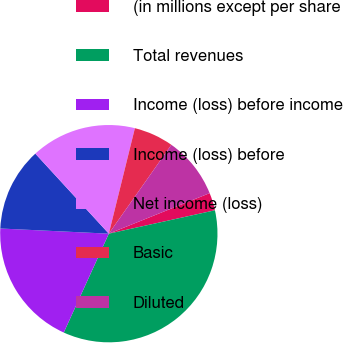<chart> <loc_0><loc_0><loc_500><loc_500><pie_chart><fcel>(in millions except per share<fcel>Total revenues<fcel>Income (loss) before income<fcel>Income (loss) before<fcel>Net income (loss)<fcel>Basic<fcel>Diluted<nl><fcel>2.63%<fcel>35.26%<fcel>18.95%<fcel>12.42%<fcel>15.68%<fcel>5.9%<fcel>9.16%<nl></chart> 